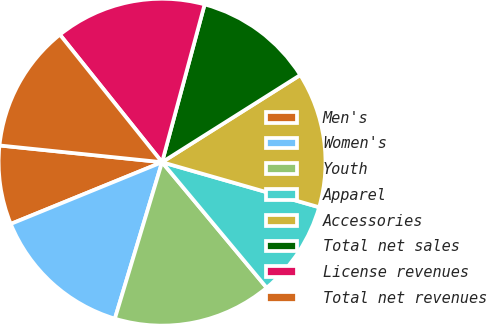Convert chart to OTSL. <chart><loc_0><loc_0><loc_500><loc_500><pie_chart><fcel>Men's<fcel>Women's<fcel>Youth<fcel>Apparel<fcel>Accessories<fcel>Total net sales<fcel>License revenues<fcel>Total net revenues<nl><fcel>7.8%<fcel>14.17%<fcel>15.72%<fcel>9.5%<fcel>13.4%<fcel>11.85%<fcel>14.94%<fcel>12.62%<nl></chart> 